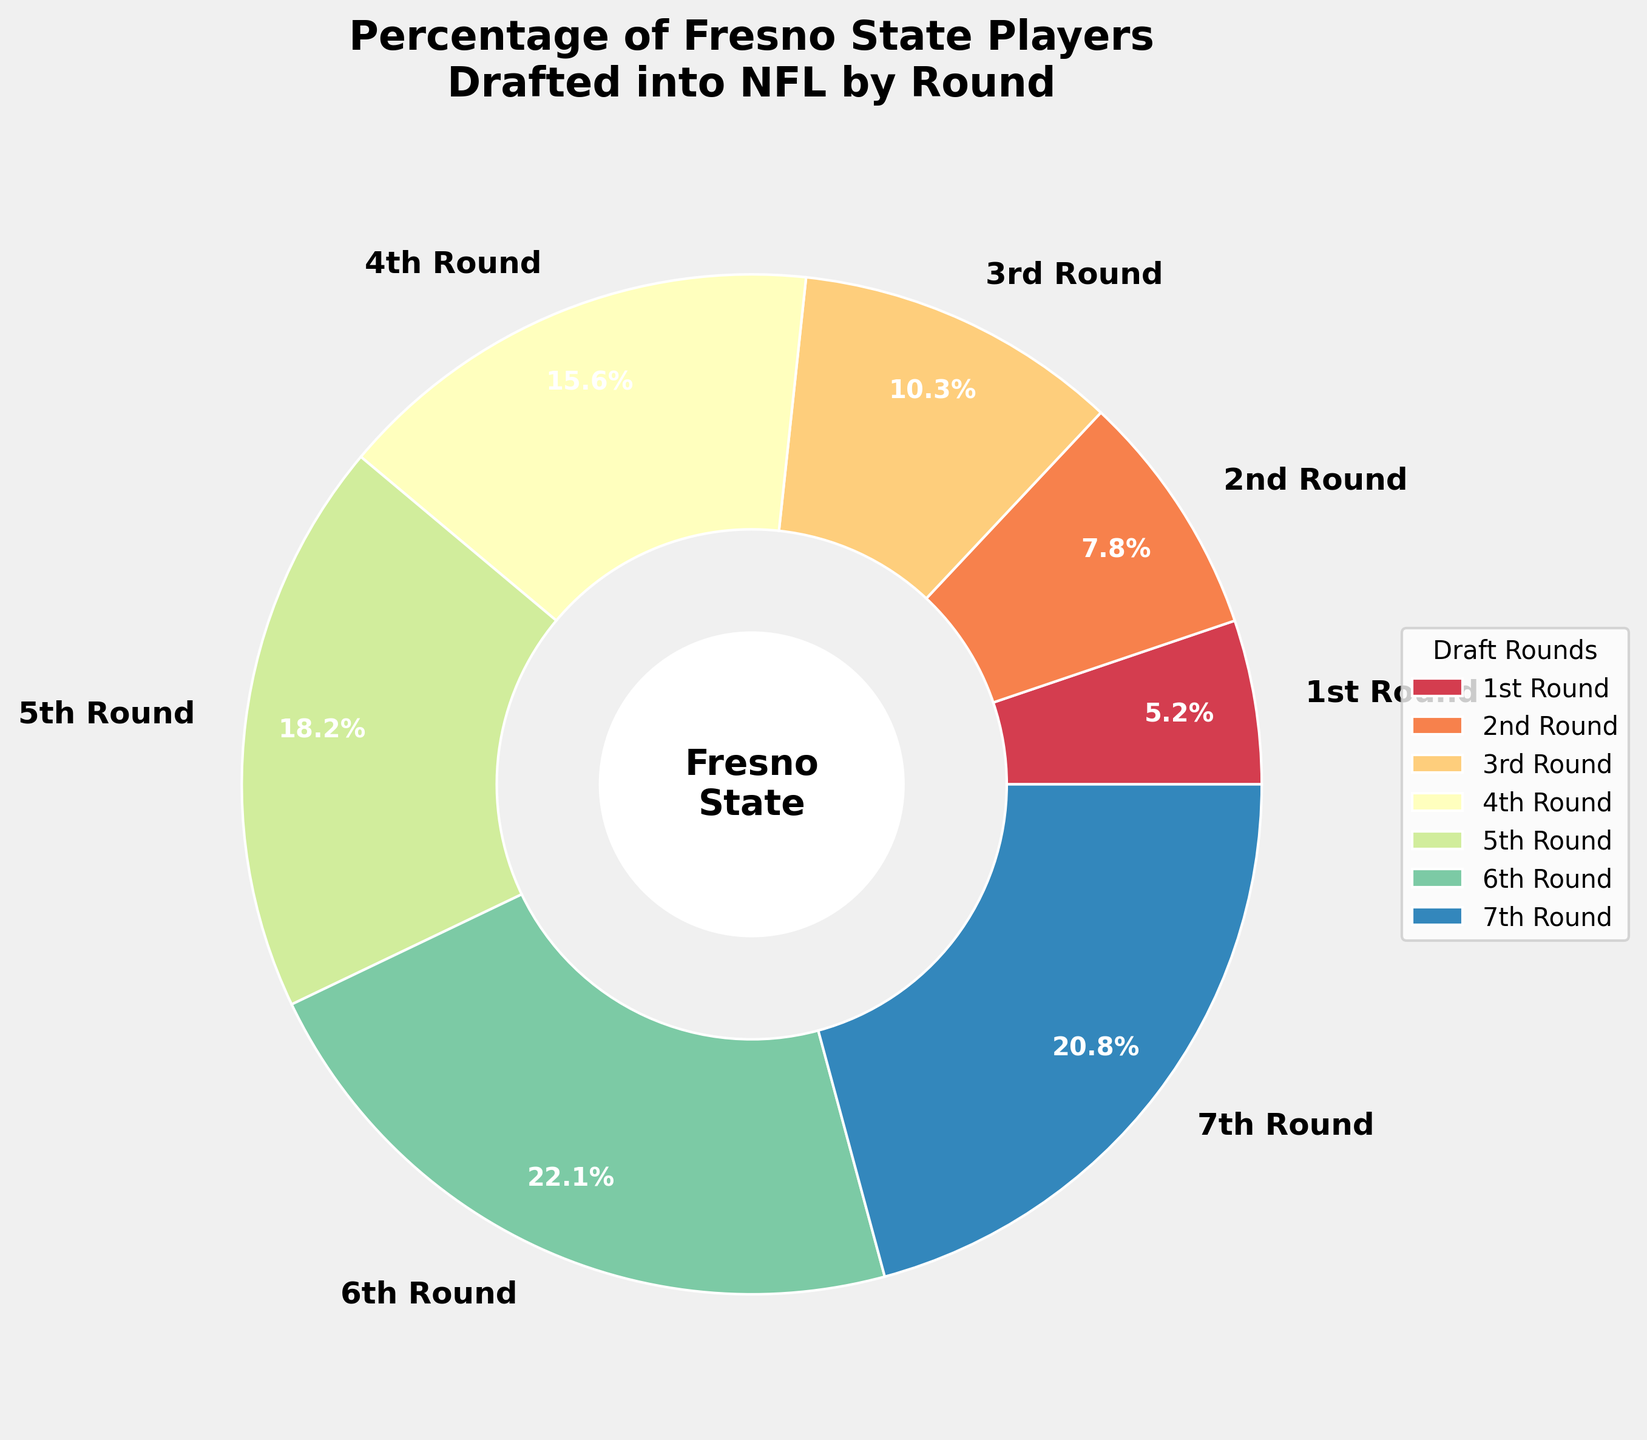What percentage of Fresno State players were drafted in the 1st Round? According to the pie chart, the percentage of Fresno State players drafted in the 1st Round is labeled directly on the segment.
Answer: 5.2% Which draft round had the highest percentage of Fresno State players drafted? By looking at the pie chart, the largest segment represents the 6th Round.
Answer: 6th Round What is the total percentage of Fresno State players drafted in the 5th and 6th Rounds combined? Adding the percentages from the 5th and 6th Rounds: 18.2% + 22.1% = 40.3%
Answer: 40.3% How does the percentage of players drafted in the 7th Round compare to the percentage of players drafted in the 6th Round? The pie chart shows that the 6th Round segment is slightly larger than the 7th Round segment. The values are 22.1% for the 6th Round and 20.8% for the 7th Round, meaning the 6th Round has a higher percentage.
Answer: 6th Round > 7th Round Is the percentage of Fresno State players drafted in the 3rd Round greater than the percentage of those drafted in the 2nd Round? Comparing the percentages from the pie chart, the 3rd Round (10.3%) is greater than the 2nd Round (7.8%).
Answer: Yes What is the combined percentage of Fresno State players drafted in the 1st, 2nd, and 3rd Rounds? Adding the percentages from the 1st, 2nd, and 3rd Rounds: 5.2% + 7.8% + 10.3% = 23.3%
Answer: 23.3% Which draft rounds have a percentage greater than 15%? According to the pie chart, the rounds with a percentage greater than 15% are the 4th Round (15.6%), 5th Round (18.2%), 6th Round (22.1%), and 7th Round (20.8%).
Answer: 4th, 5th, 6th, and 7th Rounds Identify the round with the smallest percentage of Fresno State players drafted? The smallest segment in the pie chart represents the 1st Round with 5.2%.
Answer: 1st Round If we compare the percentages of the 4th and 7th Rounds, which one is higher and by how much? The 4th Round has 15.6%, and the 7th Round has 20.8%. The difference is 20.8% - 15.6% = 5.2%.
Answer: 7th Round by 5.2% What percentage of players were drafted in rounds 1 through 4 combined? Adding the percentages from the 1st, 2nd, 3rd, and 4th Rounds: 5.2% + 7.8% + 10.3% + 15.6% = 38.9%
Answer: 38.9% 